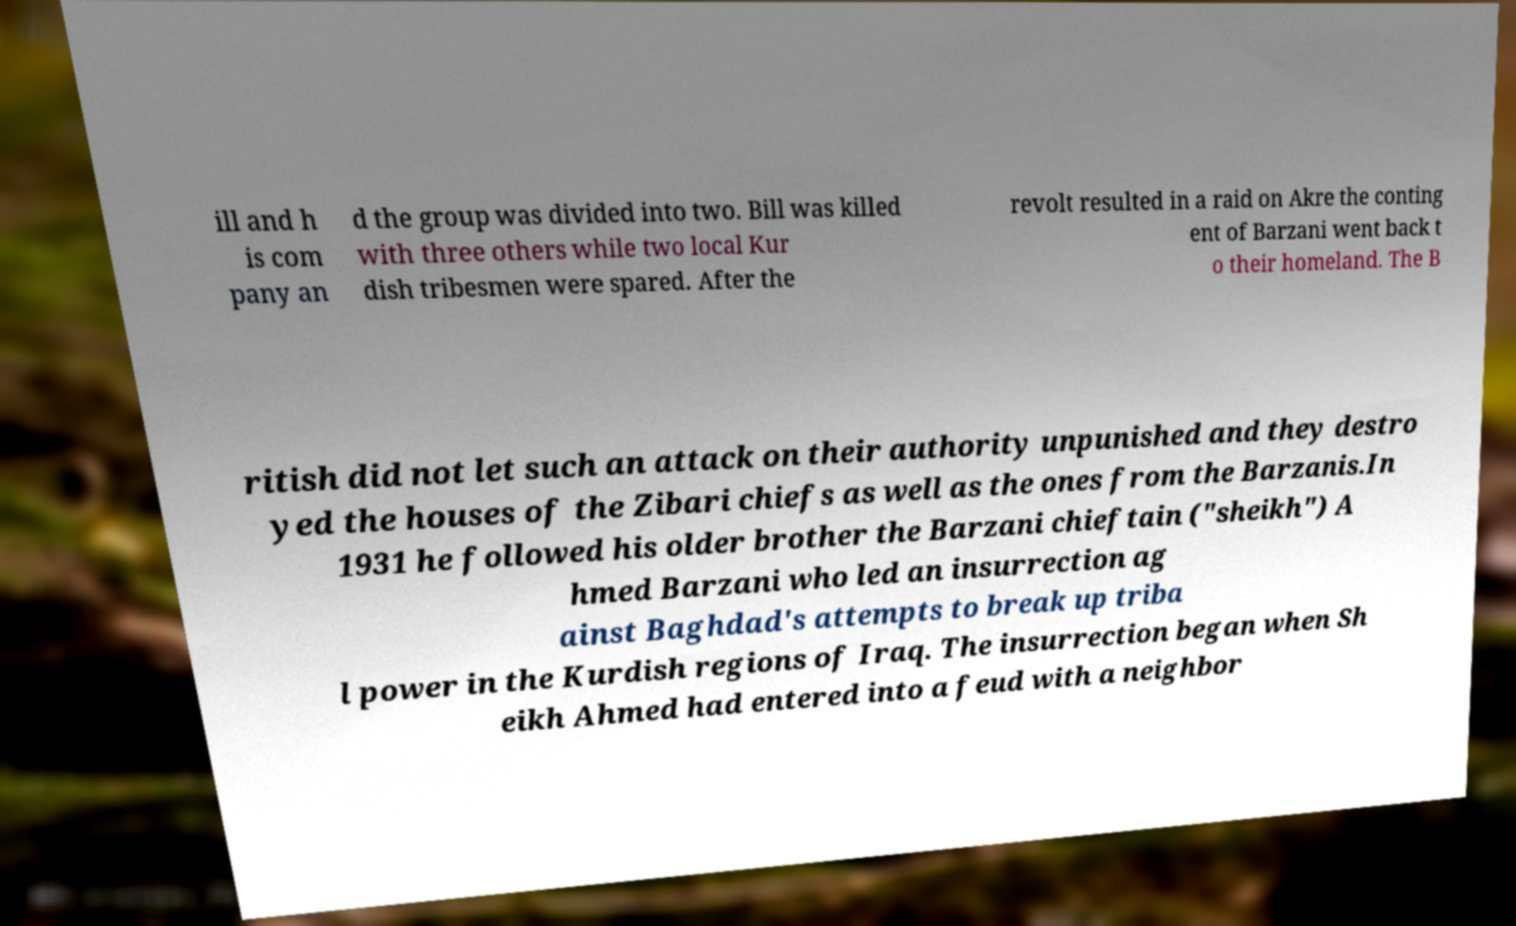Please read and relay the text visible in this image. What does it say? ill and h is com pany an d the group was divided into two. Bill was killed with three others while two local Kur dish tribesmen were spared. After the revolt resulted in a raid on Akre the conting ent of Barzani went back t o their homeland. The B ritish did not let such an attack on their authority unpunished and they destro yed the houses of the Zibari chiefs as well as the ones from the Barzanis.In 1931 he followed his older brother the Barzani chieftain ("sheikh") A hmed Barzani who led an insurrection ag ainst Baghdad's attempts to break up triba l power in the Kurdish regions of Iraq. The insurrection began when Sh eikh Ahmed had entered into a feud with a neighbor 